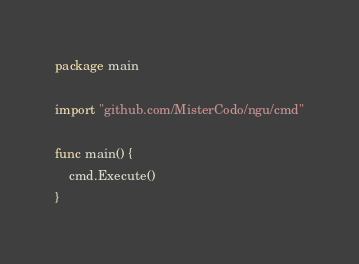Convert code to text. <code><loc_0><loc_0><loc_500><loc_500><_Go_>package main

import "github.com/MisterCodo/ngu/cmd"

func main() {
	cmd.Execute()
}
</code> 